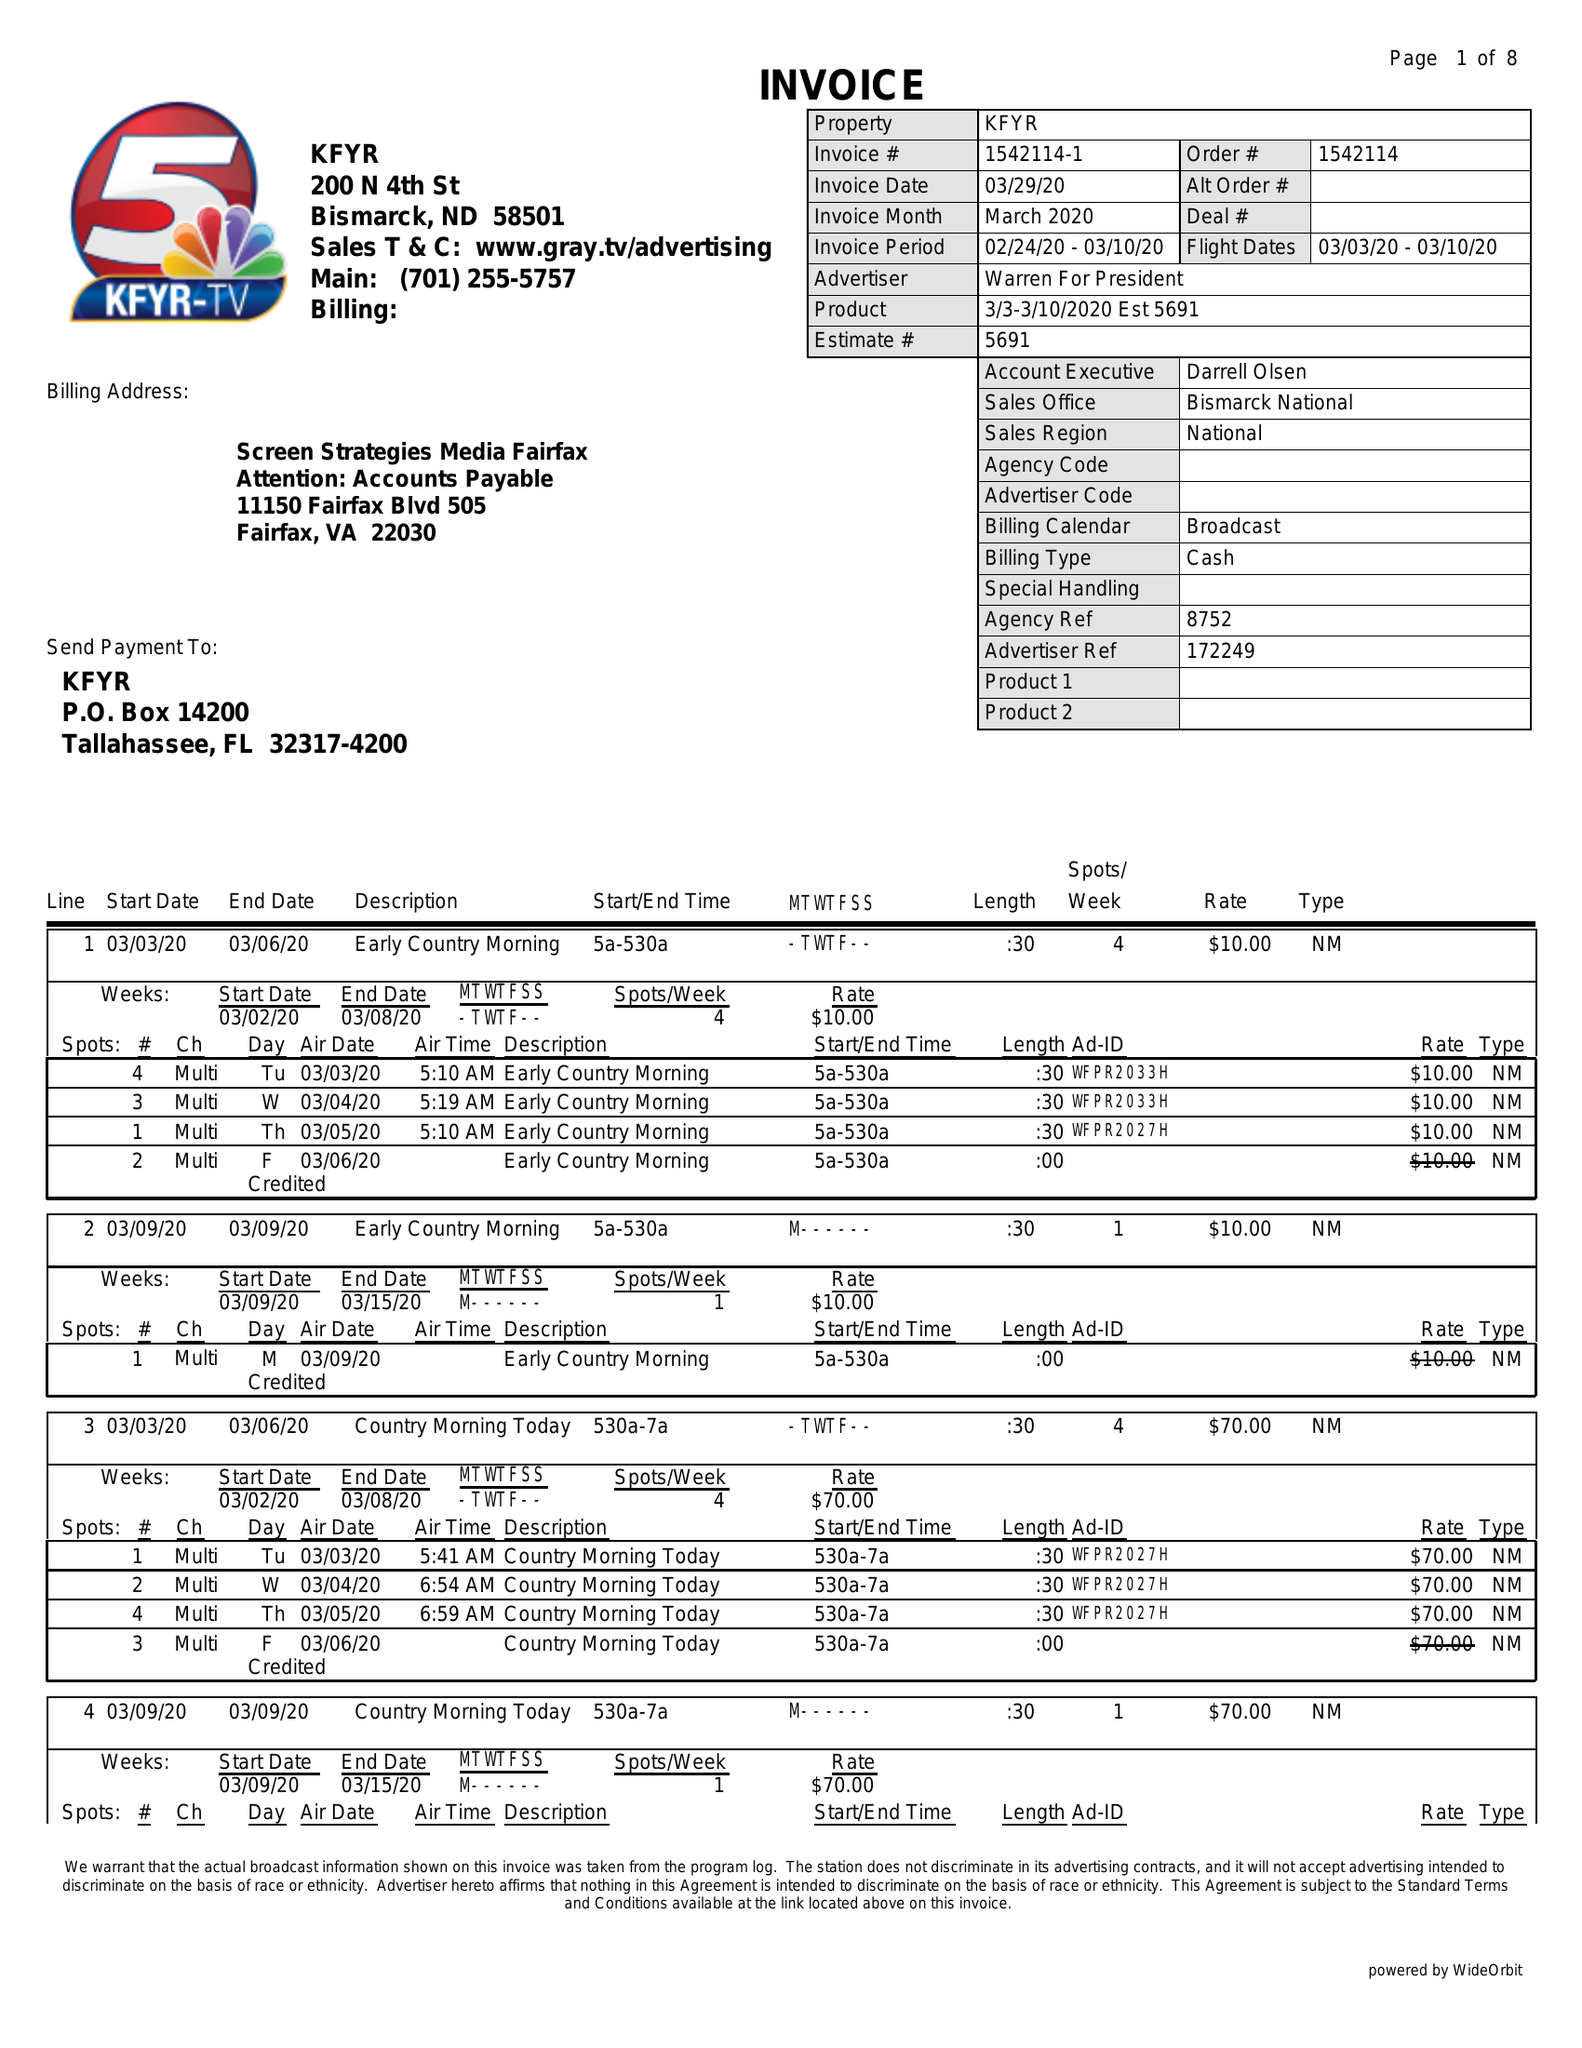What is the value for the contract_num?
Answer the question using a single word or phrase. 1542114 